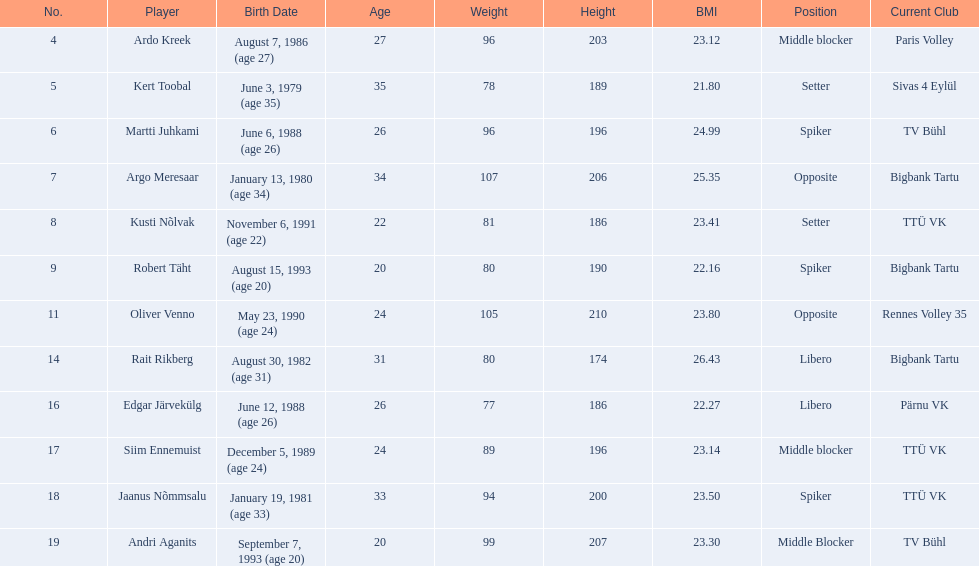Who are the players of the estonian men's national volleyball team? Ardo Kreek, Kert Toobal, Martti Juhkami, Argo Meresaar, Kusti Nõlvak, Robert Täht, Oliver Venno, Rait Rikberg, Edgar Järvekülg, Siim Ennemuist, Jaanus Nõmmsalu, Andri Aganits. Of these, which have a height over 200? Ardo Kreek, Argo Meresaar, Oliver Venno, Andri Aganits. Of the remaining, who is the tallest? Oliver Venno. 